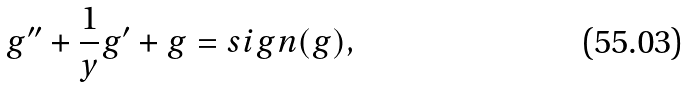<formula> <loc_0><loc_0><loc_500><loc_500>g ^ { \prime \prime } + \frac { 1 } { y } g ^ { \prime } + g = s i g n ( g ) ,</formula> 